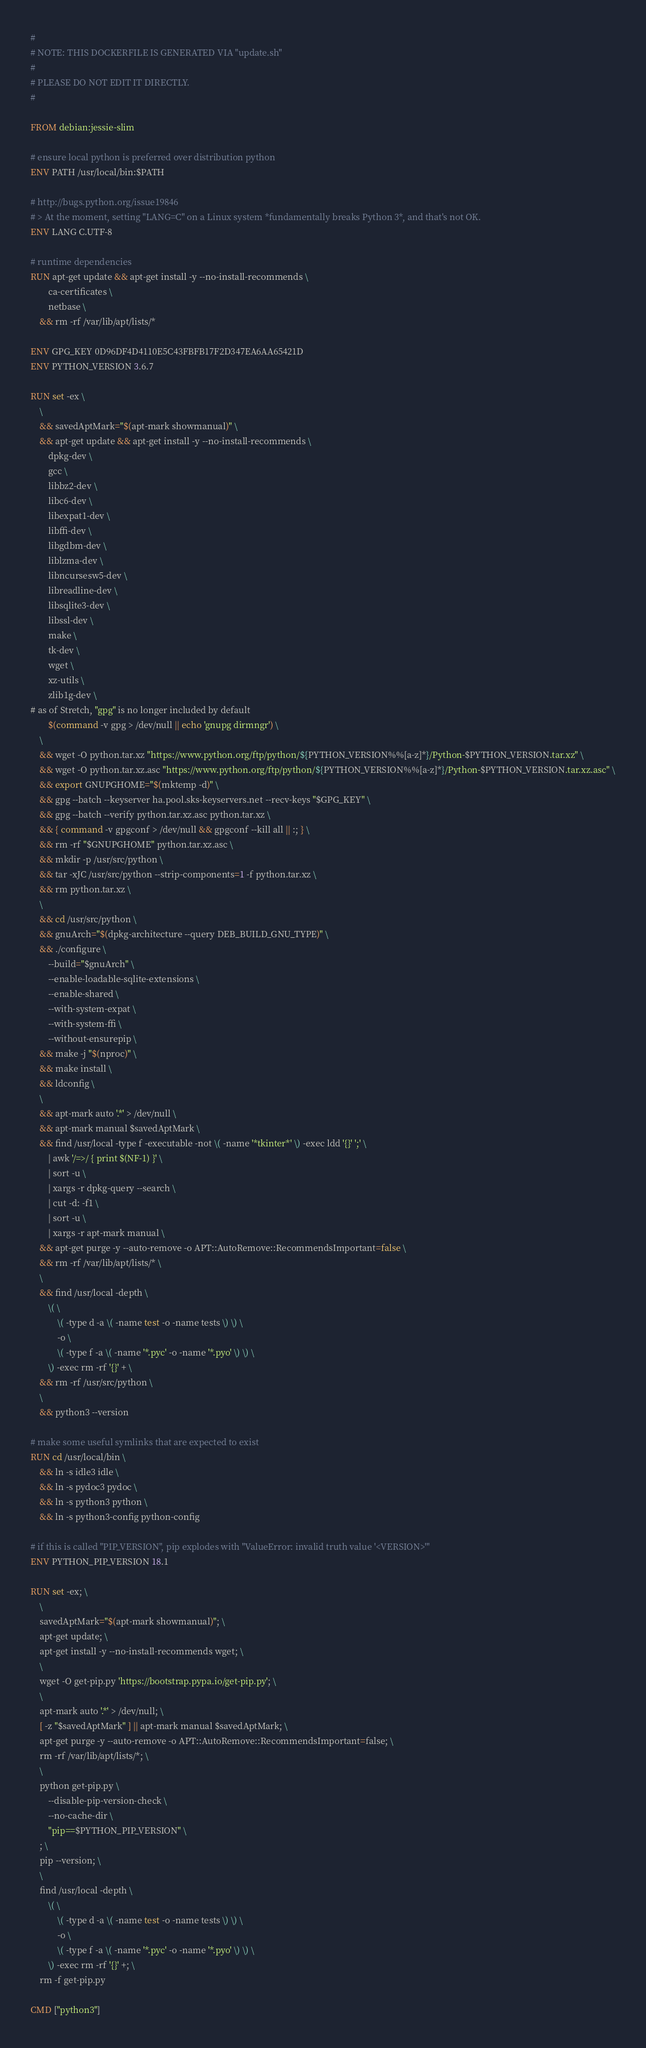Convert code to text. <code><loc_0><loc_0><loc_500><loc_500><_Dockerfile_>#
# NOTE: THIS DOCKERFILE IS GENERATED VIA "update.sh"
#
# PLEASE DO NOT EDIT IT DIRECTLY.
#

FROM debian:jessie-slim

# ensure local python is preferred over distribution python
ENV PATH /usr/local/bin:$PATH

# http://bugs.python.org/issue19846
# > At the moment, setting "LANG=C" on a Linux system *fundamentally breaks Python 3*, and that's not OK.
ENV LANG C.UTF-8

# runtime dependencies
RUN apt-get update && apt-get install -y --no-install-recommends \
		ca-certificates \
		netbase \
	&& rm -rf /var/lib/apt/lists/*

ENV GPG_KEY 0D96DF4D4110E5C43FBFB17F2D347EA6AA65421D
ENV PYTHON_VERSION 3.6.7

RUN set -ex \
	\
	&& savedAptMark="$(apt-mark showmanual)" \
	&& apt-get update && apt-get install -y --no-install-recommends \
		dpkg-dev \
		gcc \
		libbz2-dev \
		libc6-dev \
		libexpat1-dev \
		libffi-dev \
		libgdbm-dev \
		liblzma-dev \
		libncursesw5-dev \
		libreadline-dev \
		libsqlite3-dev \
		libssl-dev \
		make \
		tk-dev \
		wget \
		xz-utils \
		zlib1g-dev \
# as of Stretch, "gpg" is no longer included by default
		$(command -v gpg > /dev/null || echo 'gnupg dirmngr') \
	\
	&& wget -O python.tar.xz "https://www.python.org/ftp/python/${PYTHON_VERSION%%[a-z]*}/Python-$PYTHON_VERSION.tar.xz" \
	&& wget -O python.tar.xz.asc "https://www.python.org/ftp/python/${PYTHON_VERSION%%[a-z]*}/Python-$PYTHON_VERSION.tar.xz.asc" \
	&& export GNUPGHOME="$(mktemp -d)" \
	&& gpg --batch --keyserver ha.pool.sks-keyservers.net --recv-keys "$GPG_KEY" \
	&& gpg --batch --verify python.tar.xz.asc python.tar.xz \
	&& { command -v gpgconf > /dev/null && gpgconf --kill all || :; } \
	&& rm -rf "$GNUPGHOME" python.tar.xz.asc \
	&& mkdir -p /usr/src/python \
	&& tar -xJC /usr/src/python --strip-components=1 -f python.tar.xz \
	&& rm python.tar.xz \
	\
	&& cd /usr/src/python \
	&& gnuArch="$(dpkg-architecture --query DEB_BUILD_GNU_TYPE)" \
	&& ./configure \
		--build="$gnuArch" \
		--enable-loadable-sqlite-extensions \
		--enable-shared \
		--with-system-expat \
		--with-system-ffi \
		--without-ensurepip \
	&& make -j "$(nproc)" \
	&& make install \
	&& ldconfig \
	\
	&& apt-mark auto '.*' > /dev/null \
	&& apt-mark manual $savedAptMark \
	&& find /usr/local -type f -executable -not \( -name '*tkinter*' \) -exec ldd '{}' ';' \
		| awk '/=>/ { print $(NF-1) }' \
		| sort -u \
		| xargs -r dpkg-query --search \
		| cut -d: -f1 \
		| sort -u \
		| xargs -r apt-mark manual \
	&& apt-get purge -y --auto-remove -o APT::AutoRemove::RecommendsImportant=false \
	&& rm -rf /var/lib/apt/lists/* \
	\
	&& find /usr/local -depth \
		\( \
			\( -type d -a \( -name test -o -name tests \) \) \
			-o \
			\( -type f -a \( -name '*.pyc' -o -name '*.pyo' \) \) \
		\) -exec rm -rf '{}' + \
	&& rm -rf /usr/src/python \
	\
	&& python3 --version

# make some useful symlinks that are expected to exist
RUN cd /usr/local/bin \
	&& ln -s idle3 idle \
	&& ln -s pydoc3 pydoc \
	&& ln -s python3 python \
	&& ln -s python3-config python-config

# if this is called "PIP_VERSION", pip explodes with "ValueError: invalid truth value '<VERSION>'"
ENV PYTHON_PIP_VERSION 18.1

RUN set -ex; \
	\
	savedAptMark="$(apt-mark showmanual)"; \
	apt-get update; \
	apt-get install -y --no-install-recommends wget; \
	\
	wget -O get-pip.py 'https://bootstrap.pypa.io/get-pip.py'; \
	\
	apt-mark auto '.*' > /dev/null; \
	[ -z "$savedAptMark" ] || apt-mark manual $savedAptMark; \
	apt-get purge -y --auto-remove -o APT::AutoRemove::RecommendsImportant=false; \
	rm -rf /var/lib/apt/lists/*; \
	\
	python get-pip.py \
		--disable-pip-version-check \
		--no-cache-dir \
		"pip==$PYTHON_PIP_VERSION" \
	; \
	pip --version; \
	\
	find /usr/local -depth \
		\( \
			\( -type d -a \( -name test -o -name tests \) \) \
			-o \
			\( -type f -a \( -name '*.pyc' -o -name '*.pyo' \) \) \
		\) -exec rm -rf '{}' +; \
	rm -f get-pip.py

CMD ["python3"]
</code> 